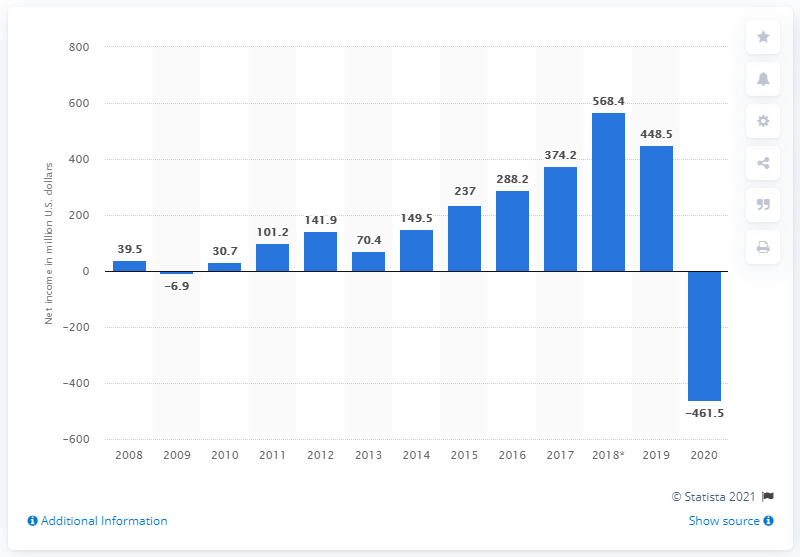Indicate a few pertinent items in this graphic. Aramark's net income in 2019 was $448.5 million. 